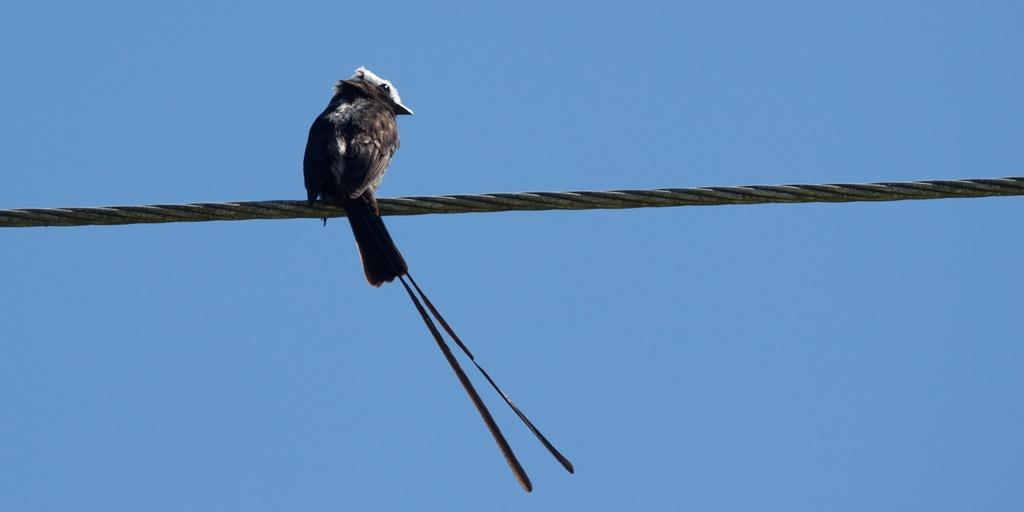What type of animal is in the image? There is a bird in the image. What is the bird doing in the image? The bird is standing on a rope. How many spiders are crawling on the branch in the image? There is no branch or spiders present in the image; it features a bird standing on a rope. What type of wren can be seen in the image? There is no wren mentioned or visible in the image; it only features a bird standing on a rope. 